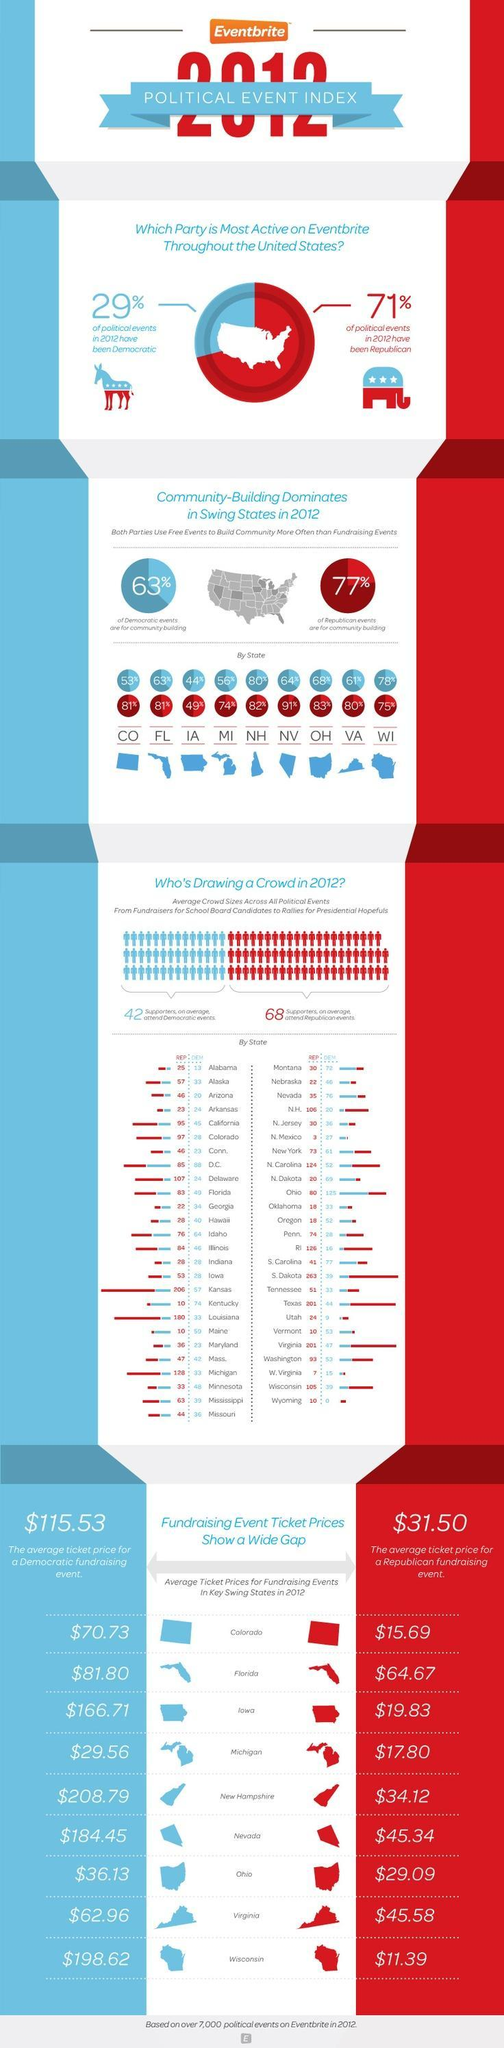Which party, has a higher share of political events in the US in 2012?
Answer the question with a short phrase. Republican What is the number of supporters for Democratic events in Colorado? 28 Which state had the highest average ticket price for democratic fundraising event and how much was it? New Hampshire, $208.79 Which political group is represented by the donkey? Democratic Which state has the highest number of supporters for Democratic events? Ohio What percentage of political events in 2012 have been democratic? 29% What is the number of supporters for Republican events in Colorado? 97 What % of republican events are used for community building in Niveda (NV)? 91% Which party has more supporters for their political events? Republican Which state has a highest number of supporters for Republican events? S. Dakota What percentage of republican events are for community building in the US? 77% What percentage of political events in 2012 have been republican? 71% What % of democratic events are used for community building in Ohio (OH)? 68% What is the average ticket pricing for a Republican fundraising event in the US? $31.50 What % of republican events are used for community building in Ohio (OH)? 83% Which political group is represented by the elephant? Republican Which is the colour used to represent the Republicans - white, blue or red? Red What percentage of democratic events are for community building? 63% Which state has the highest average ticket price for Republican fundraising event and how much was it? Florida, $64.67 What is the average ticket price for a Democratic fundraising event in the US? $115.53 What % of democratic events are used for community building in Florida (FL)? 63% What is the average ticket price for a democratic fundraising event in Iowa? $166.71 